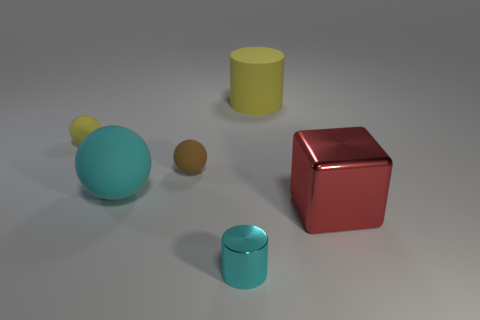Subtract all large cyan rubber balls. How many balls are left? 2 Subtract all cubes. How many objects are left? 5 Add 3 small matte spheres. How many objects exist? 9 Subtract all big cyan matte objects. Subtract all big purple metallic objects. How many objects are left? 5 Add 5 large cyan rubber objects. How many large cyan rubber objects are left? 6 Add 2 green cubes. How many green cubes exist? 2 Subtract all cyan cylinders. How many cylinders are left? 1 Subtract 1 cyan spheres. How many objects are left? 5 Subtract 1 blocks. How many blocks are left? 0 Subtract all blue blocks. Subtract all brown balls. How many blocks are left? 1 